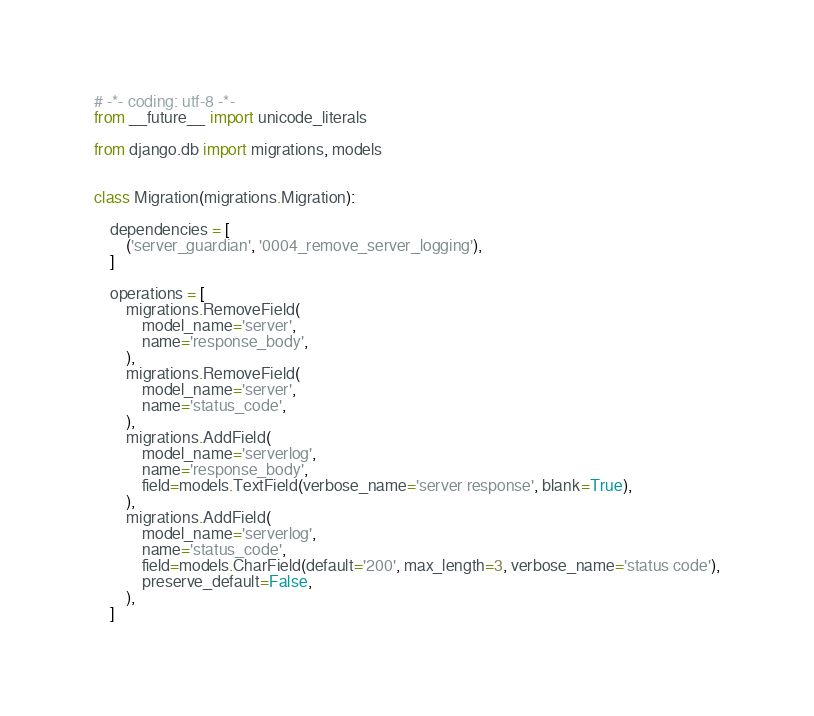Convert code to text. <code><loc_0><loc_0><loc_500><loc_500><_Python_># -*- coding: utf-8 -*-
from __future__ import unicode_literals

from django.db import migrations, models


class Migration(migrations.Migration):

    dependencies = [
        ('server_guardian', '0004_remove_server_logging'),
    ]

    operations = [
        migrations.RemoveField(
            model_name='server',
            name='response_body',
        ),
        migrations.RemoveField(
            model_name='server',
            name='status_code',
        ),
        migrations.AddField(
            model_name='serverlog',
            name='response_body',
            field=models.TextField(verbose_name='server response', blank=True),
        ),
        migrations.AddField(
            model_name='serverlog',
            name='status_code',
            field=models.CharField(default='200', max_length=3, verbose_name='status code'),
            preserve_default=False,
        ),
    ]
</code> 